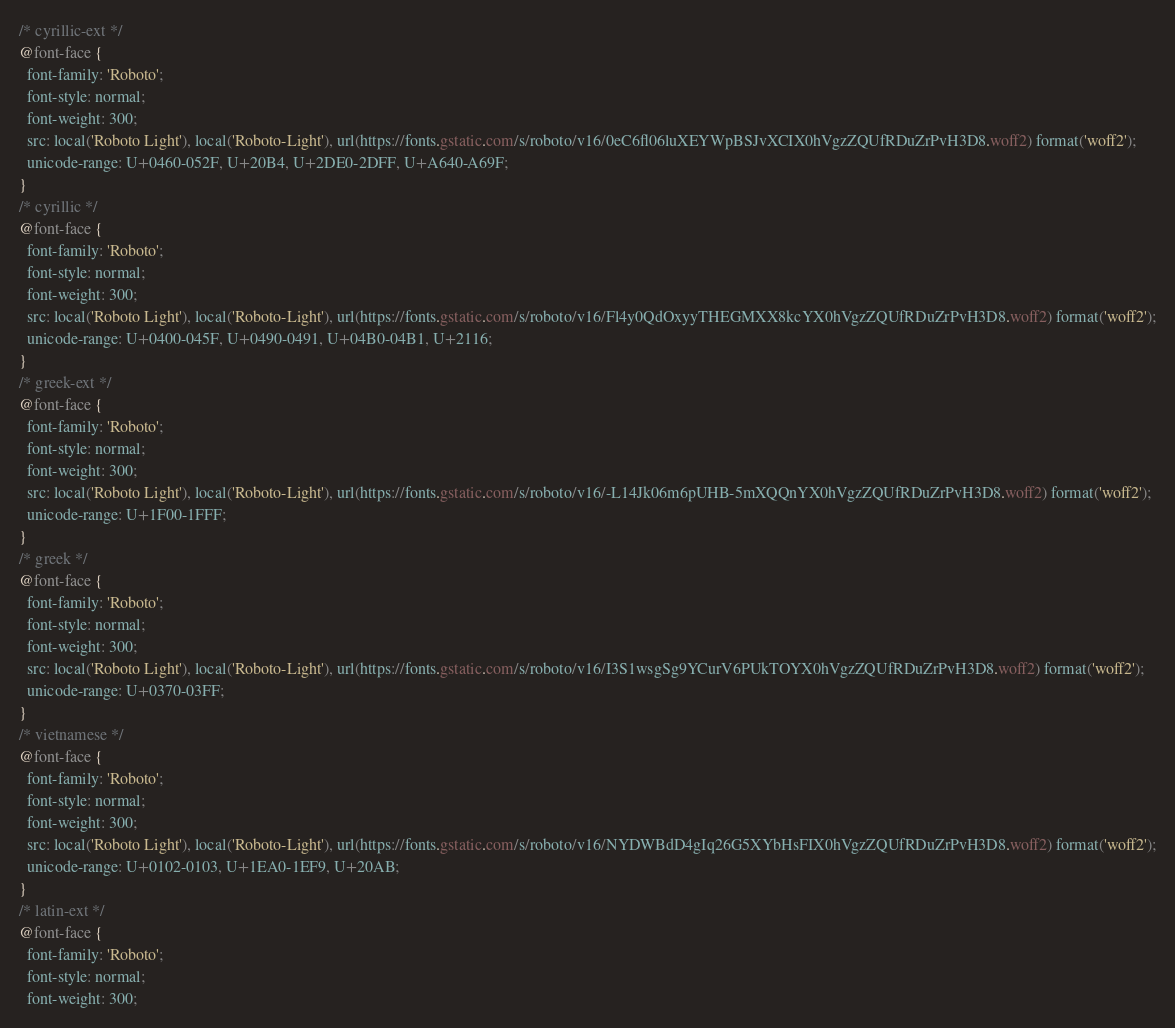Convert code to text. <code><loc_0><loc_0><loc_500><loc_500><_CSS_>/* cyrillic-ext */
@font-face {
  font-family: 'Roboto';
  font-style: normal;
  font-weight: 300;
  src: local('Roboto Light'), local('Roboto-Light'), url(https://fonts.gstatic.com/s/roboto/v16/0eC6fl06luXEYWpBSJvXCIX0hVgzZQUfRDuZrPvH3D8.woff2) format('woff2');
  unicode-range: U+0460-052F, U+20B4, U+2DE0-2DFF, U+A640-A69F;
}
/* cyrillic */
@font-face {
  font-family: 'Roboto';
  font-style: normal;
  font-weight: 300;
  src: local('Roboto Light'), local('Roboto-Light'), url(https://fonts.gstatic.com/s/roboto/v16/Fl4y0QdOxyyTHEGMXX8kcYX0hVgzZQUfRDuZrPvH3D8.woff2) format('woff2');
  unicode-range: U+0400-045F, U+0490-0491, U+04B0-04B1, U+2116;
}
/* greek-ext */
@font-face {
  font-family: 'Roboto';
  font-style: normal;
  font-weight: 300;
  src: local('Roboto Light'), local('Roboto-Light'), url(https://fonts.gstatic.com/s/roboto/v16/-L14Jk06m6pUHB-5mXQQnYX0hVgzZQUfRDuZrPvH3D8.woff2) format('woff2');
  unicode-range: U+1F00-1FFF;
}
/* greek */
@font-face {
  font-family: 'Roboto';
  font-style: normal;
  font-weight: 300;
  src: local('Roboto Light'), local('Roboto-Light'), url(https://fonts.gstatic.com/s/roboto/v16/I3S1wsgSg9YCurV6PUkTOYX0hVgzZQUfRDuZrPvH3D8.woff2) format('woff2');
  unicode-range: U+0370-03FF;
}
/* vietnamese */
@font-face {
  font-family: 'Roboto';
  font-style: normal;
  font-weight: 300;
  src: local('Roboto Light'), local('Roboto-Light'), url(https://fonts.gstatic.com/s/roboto/v16/NYDWBdD4gIq26G5XYbHsFIX0hVgzZQUfRDuZrPvH3D8.woff2) format('woff2');
  unicode-range: U+0102-0103, U+1EA0-1EF9, U+20AB;
}
/* latin-ext */
@font-face {
  font-family: 'Roboto';
  font-style: normal;
  font-weight: 300;</code> 